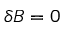<formula> <loc_0><loc_0><loc_500><loc_500>\delta B = 0</formula> 